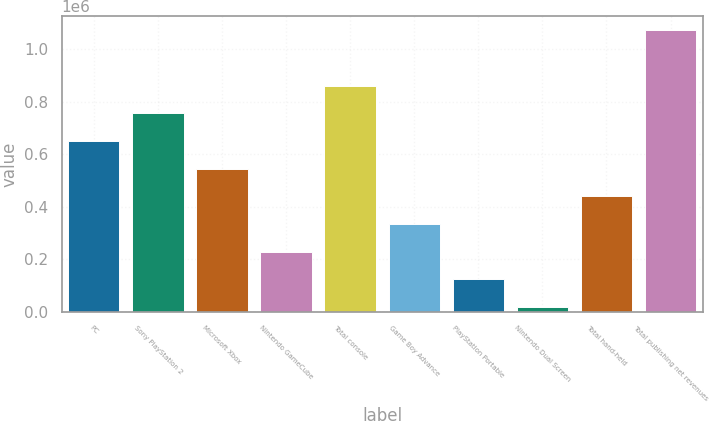<chart> <loc_0><loc_0><loc_500><loc_500><bar_chart><fcel>PC<fcel>Sony PlayStation 2<fcel>Microsoft Xbox<fcel>Nintendo GameCube<fcel>Total console<fcel>Game Boy Advance<fcel>PlayStation Portable<fcel>Nintendo Dual Screen<fcel>Total hand-held<fcel>Total publishing net revenues<nl><fcel>650717<fcel>756220<fcel>545214<fcel>228705<fcel>861723<fcel>334208<fcel>123202<fcel>17699<fcel>439711<fcel>1.07273e+06<nl></chart> 